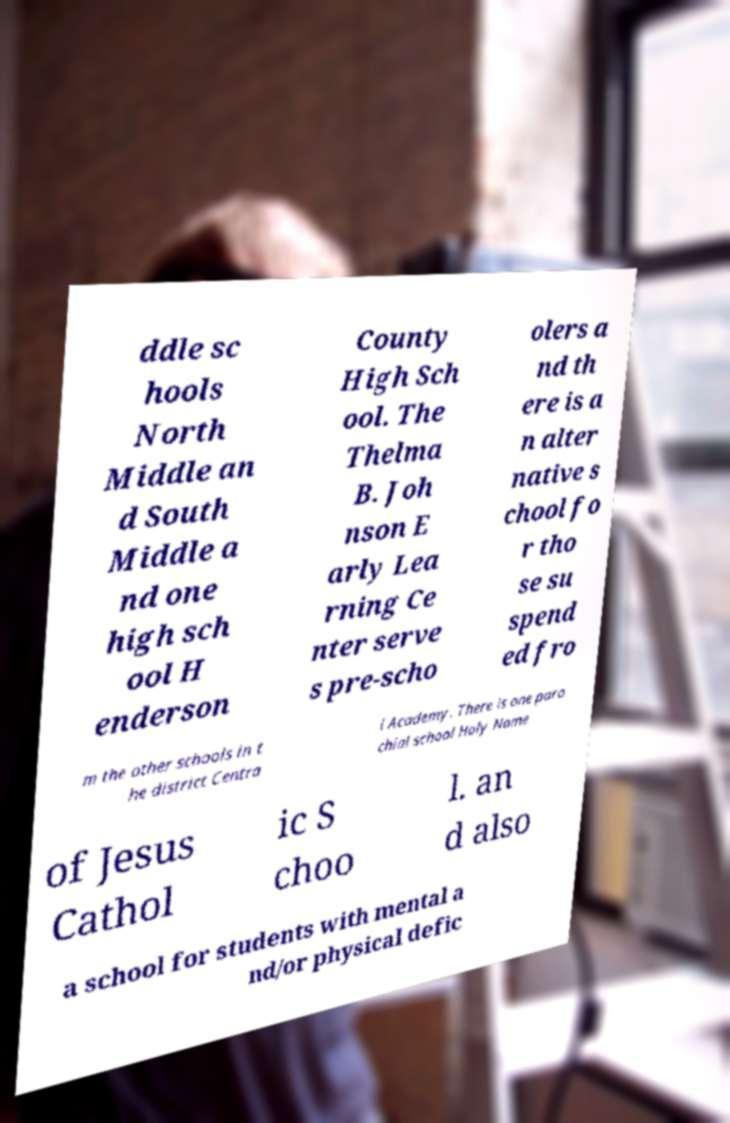For documentation purposes, I need the text within this image transcribed. Could you provide that? ddle sc hools North Middle an d South Middle a nd one high sch ool H enderson County High Sch ool. The Thelma B. Joh nson E arly Lea rning Ce nter serve s pre-scho olers a nd th ere is a n alter native s chool fo r tho se su spend ed fro m the other schools in t he district Centra l Academy. There is one paro chial school Holy Name of Jesus Cathol ic S choo l. an d also a school for students with mental a nd/or physical defic 